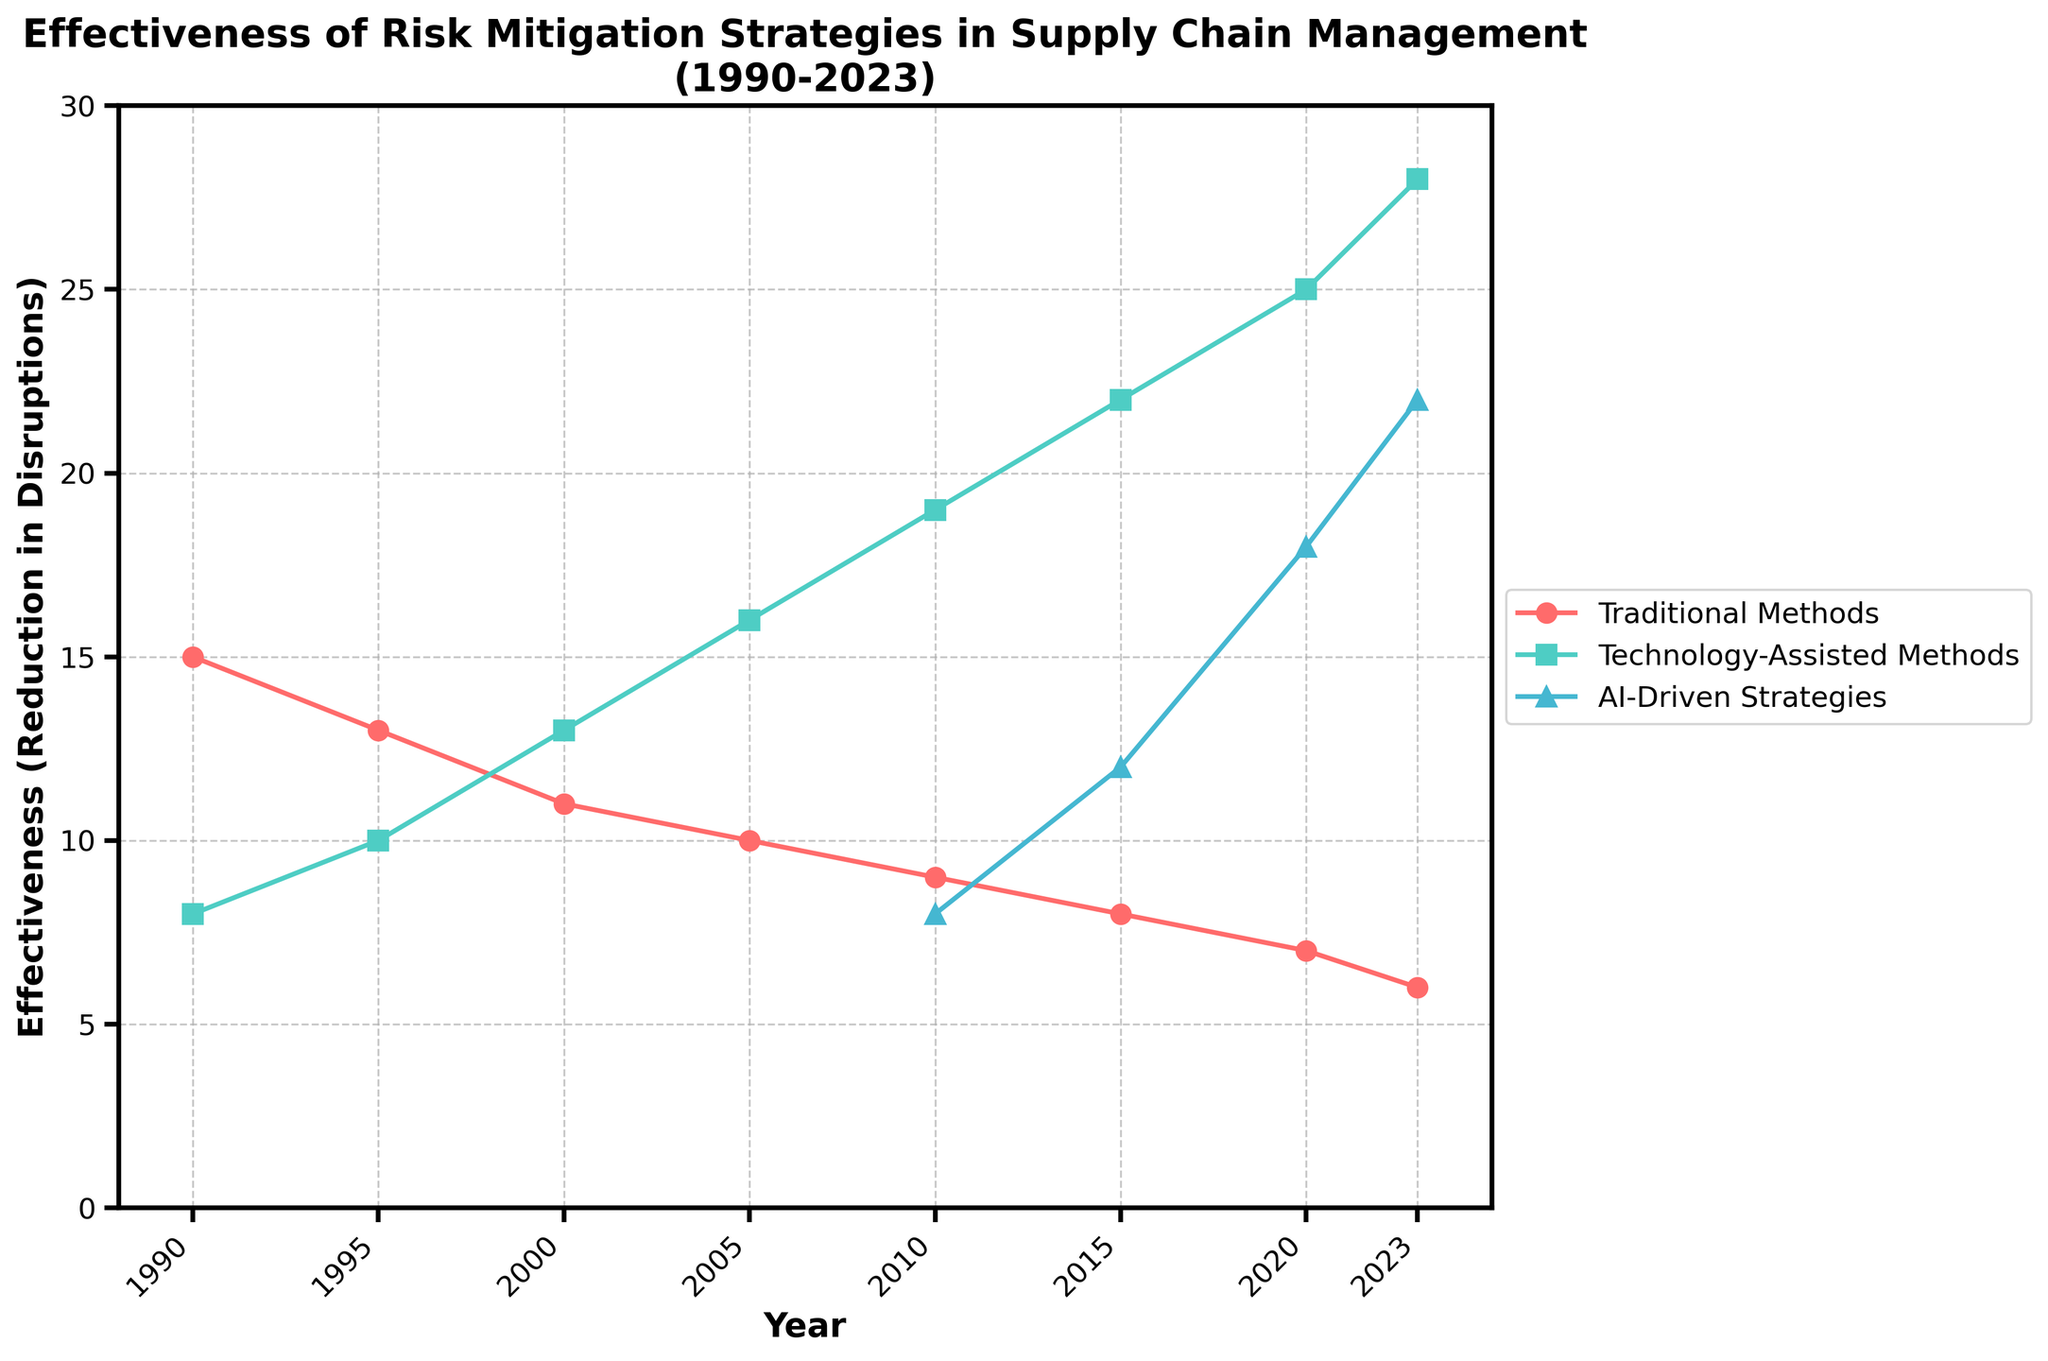What is the most effective risk mitigation strategy in 2023? The figure shows that in 2023, AI-Driven Strategies have the highest effectiveness with a reduction in disruptions of 22.
Answer: AI-Driven Strategies How did the effectiveness of Traditional Methods change from 1990 to 2023? In 1990, the effectiveness of Traditional Methods was 15, and it decreased to 6 by 2023. The change is 15 - 6 = 9.
Answer: Decreased by 9 Which strategy saw the greatest increase in effectiveness from 2005 to 2023? For Traditional Methods: 10 to 6, a change of -4. For Technology-Assisted Methods: 16 to 28, a change of 12. For AI-Driven Strategies: 5 to 22, a change of 17. The greatest increase is for AI-Driven Strategies.
Answer: AI-Driven Strategies By how many points did Technology-Assisted Methods improve from 2000 to 2023? In 2000, Technology-Assisted Methods had an effectiveness of 13 and improved to 28 in 2023. The improvement is 28 - 13 = 15.
Answer: 15 points Which strategy had the lowest effectiveness consistently over the entire period shown? Traditional Methods had consistently lower effectiveness compared to Technology-Assisted Methods and AI-Driven Strategies throughout the period from 1990 to 2023.
Answer: Traditional Methods What was the effectiveness of AI-Driven Strategies in 2015? The figure indicates that effectiveness data for AI-Driven Strategies starts from 2005 and it was 12 in 2015.
Answer: 12 Compare the effectiveness of Technology-Assisted Methods and Traditional Methods in 2010. In 2010, the effectiveness was 19 for Technology-Assisted Methods and 9 for Traditional Methods. Technology-Assisted Methods were 19 - 9 = 10 points more effective.
Answer: Technology-Assisted Methods by 10 points What trend do you observe in the effectiveness of Traditional Methods from 1990 to 2023? The effectiveness of Traditional Methods shows a consistent declining trend from 15 in 1990 to 6 in 2023.
Answer: Declining trend What is the combined effectiveness of all three strategies in 2020? In 2020, Traditional Methods were at 7, Technology-Assisted Methods at 25, and AI-Driven Strategies at 18. Combined, they are 7 + 25 + 18 = 50.
Answer: 50 